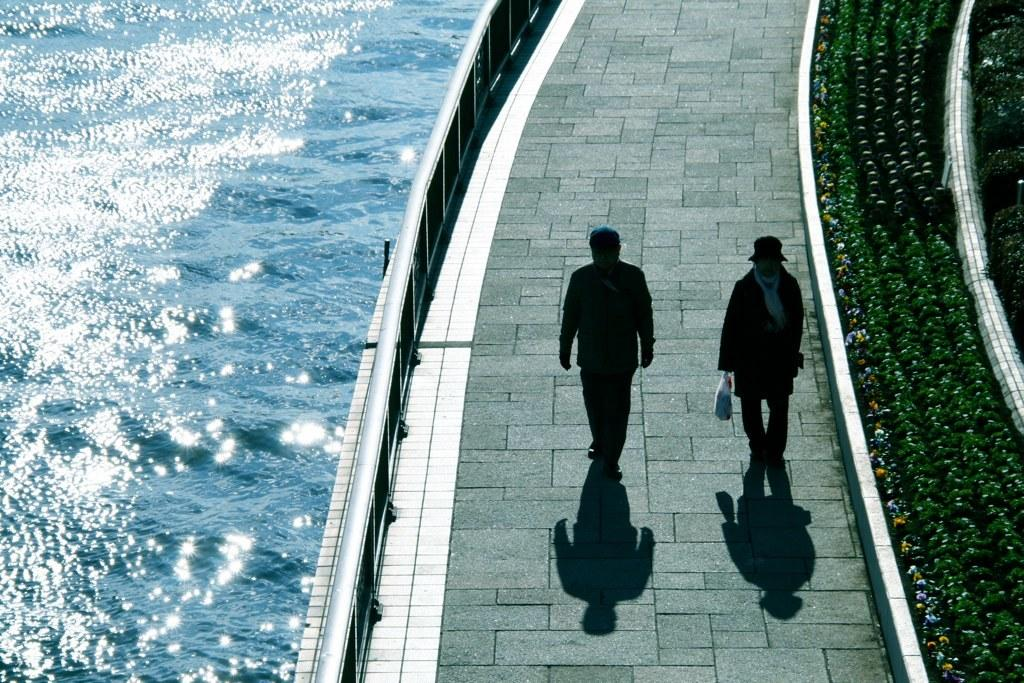How many people can be seen walking in the image? There are two people walking in the image. Where are the people walking? The people are walking on a pathway. What type of natural elements can be seen in the image? There are plants and water flowing visible in the image. What might be used to control or direct traffic in the image? There are barricades present in the image. What type of pig can be seen talking to the people in the image? There is no pig present in the image, and the people are not talking to any animals. 